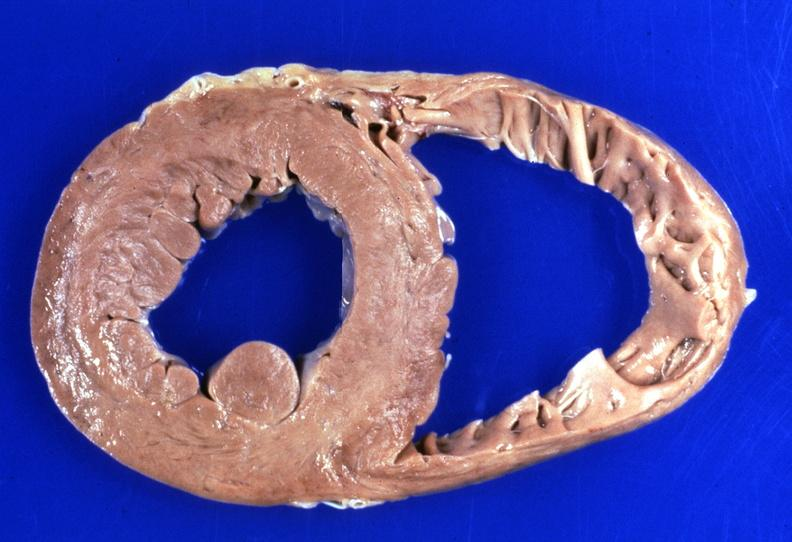s cardiovascular present?
Answer the question using a single word or phrase. Yes 